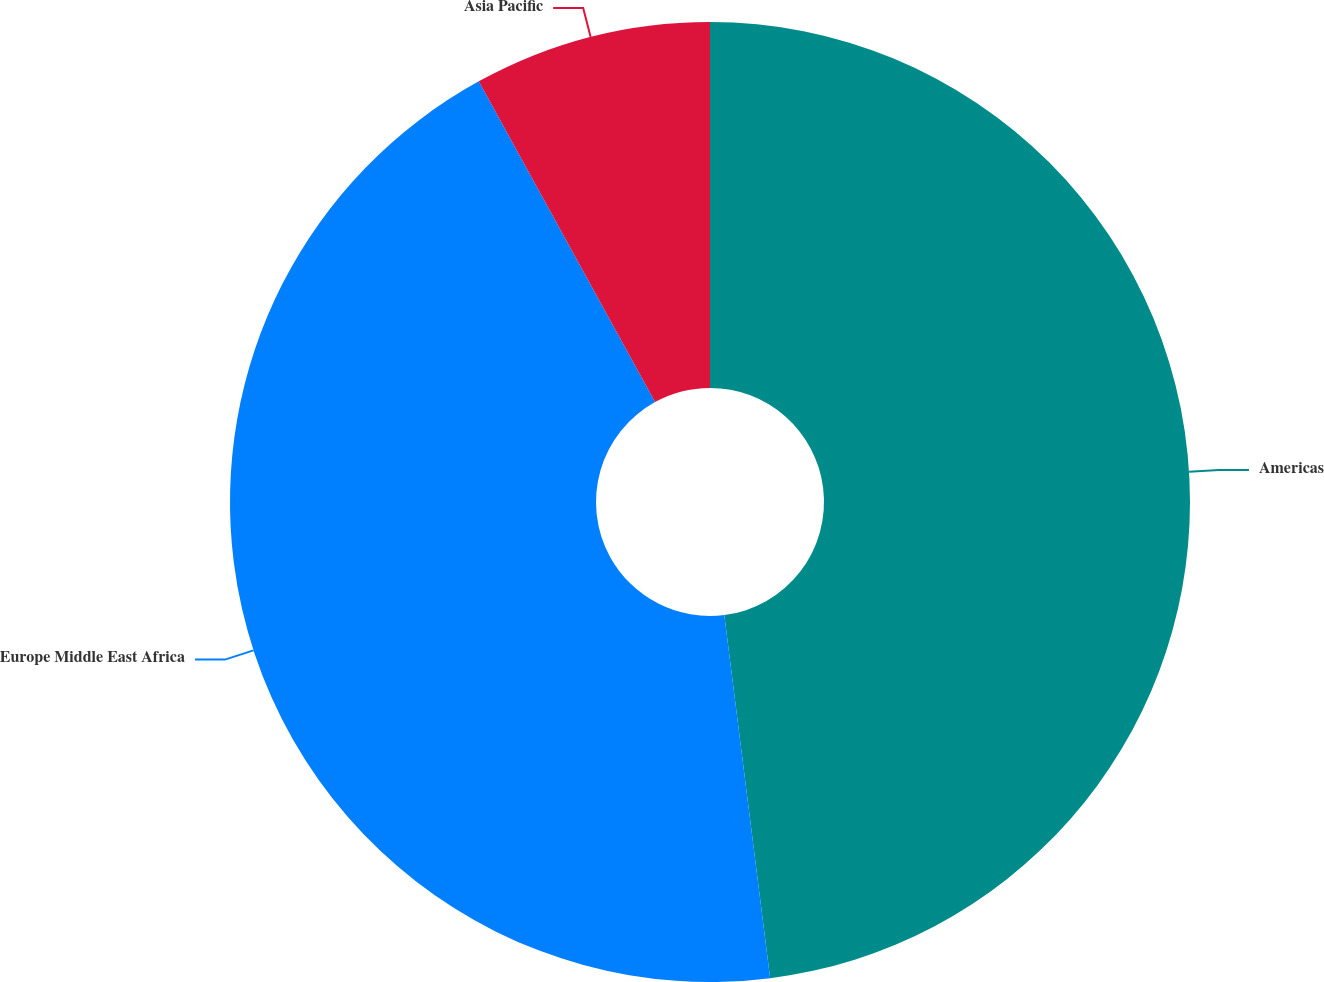Convert chart to OTSL. <chart><loc_0><loc_0><loc_500><loc_500><pie_chart><fcel>Americas<fcel>Europe Middle East Africa<fcel>Asia Pacific<nl><fcel>48.0%<fcel>44.0%<fcel>8.0%<nl></chart> 